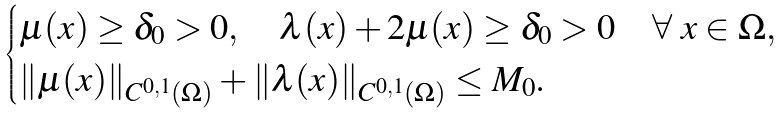<formula> <loc_0><loc_0><loc_500><loc_500>\begin{cases} \mu ( x ) \geq \delta _ { 0 } > 0 , \quad \lambda ( x ) + 2 \mu ( x ) \geq \delta _ { 0 } > 0 \quad \forall \ x \in \Omega , \\ \| \mu ( x ) \| _ { C ^ { 0 , 1 } ( \Omega ) } + \| \lambda ( x ) \| _ { C ^ { 0 , 1 } ( \Omega ) } \leq M _ { 0 } . \end{cases}</formula> 